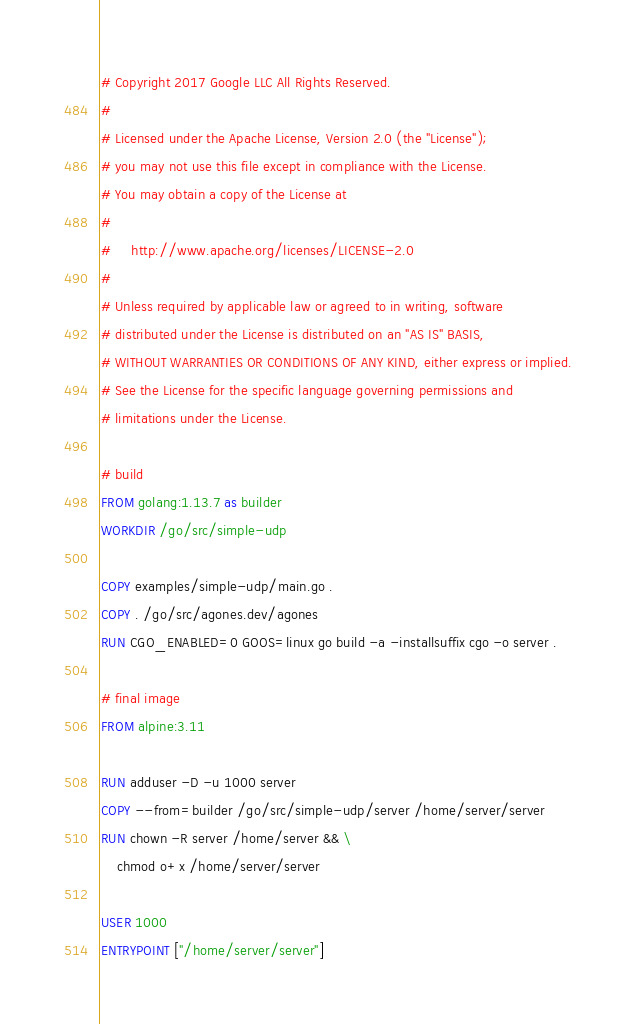Convert code to text. <code><loc_0><loc_0><loc_500><loc_500><_Dockerfile_># Copyright 2017 Google LLC All Rights Reserved.
#
# Licensed under the Apache License, Version 2.0 (the "License");
# you may not use this file except in compliance with the License.
# You may obtain a copy of the License at
#
#     http://www.apache.org/licenses/LICENSE-2.0
#
# Unless required by applicable law or agreed to in writing, software
# distributed under the License is distributed on an "AS IS" BASIS,
# WITHOUT WARRANTIES OR CONDITIONS OF ANY KIND, either express or implied.
# See the License for the specific language governing permissions and
# limitations under the License.

# build
FROM golang:1.13.7 as builder
WORKDIR /go/src/simple-udp

COPY examples/simple-udp/main.go .
COPY . /go/src/agones.dev/agones
RUN CGO_ENABLED=0 GOOS=linux go build -a -installsuffix cgo -o server .

# final image
FROM alpine:3.11

RUN adduser -D -u 1000 server
COPY --from=builder /go/src/simple-udp/server /home/server/server
RUN chown -R server /home/server && \
    chmod o+x /home/server/server

USER 1000
ENTRYPOINT ["/home/server/server"]
</code> 